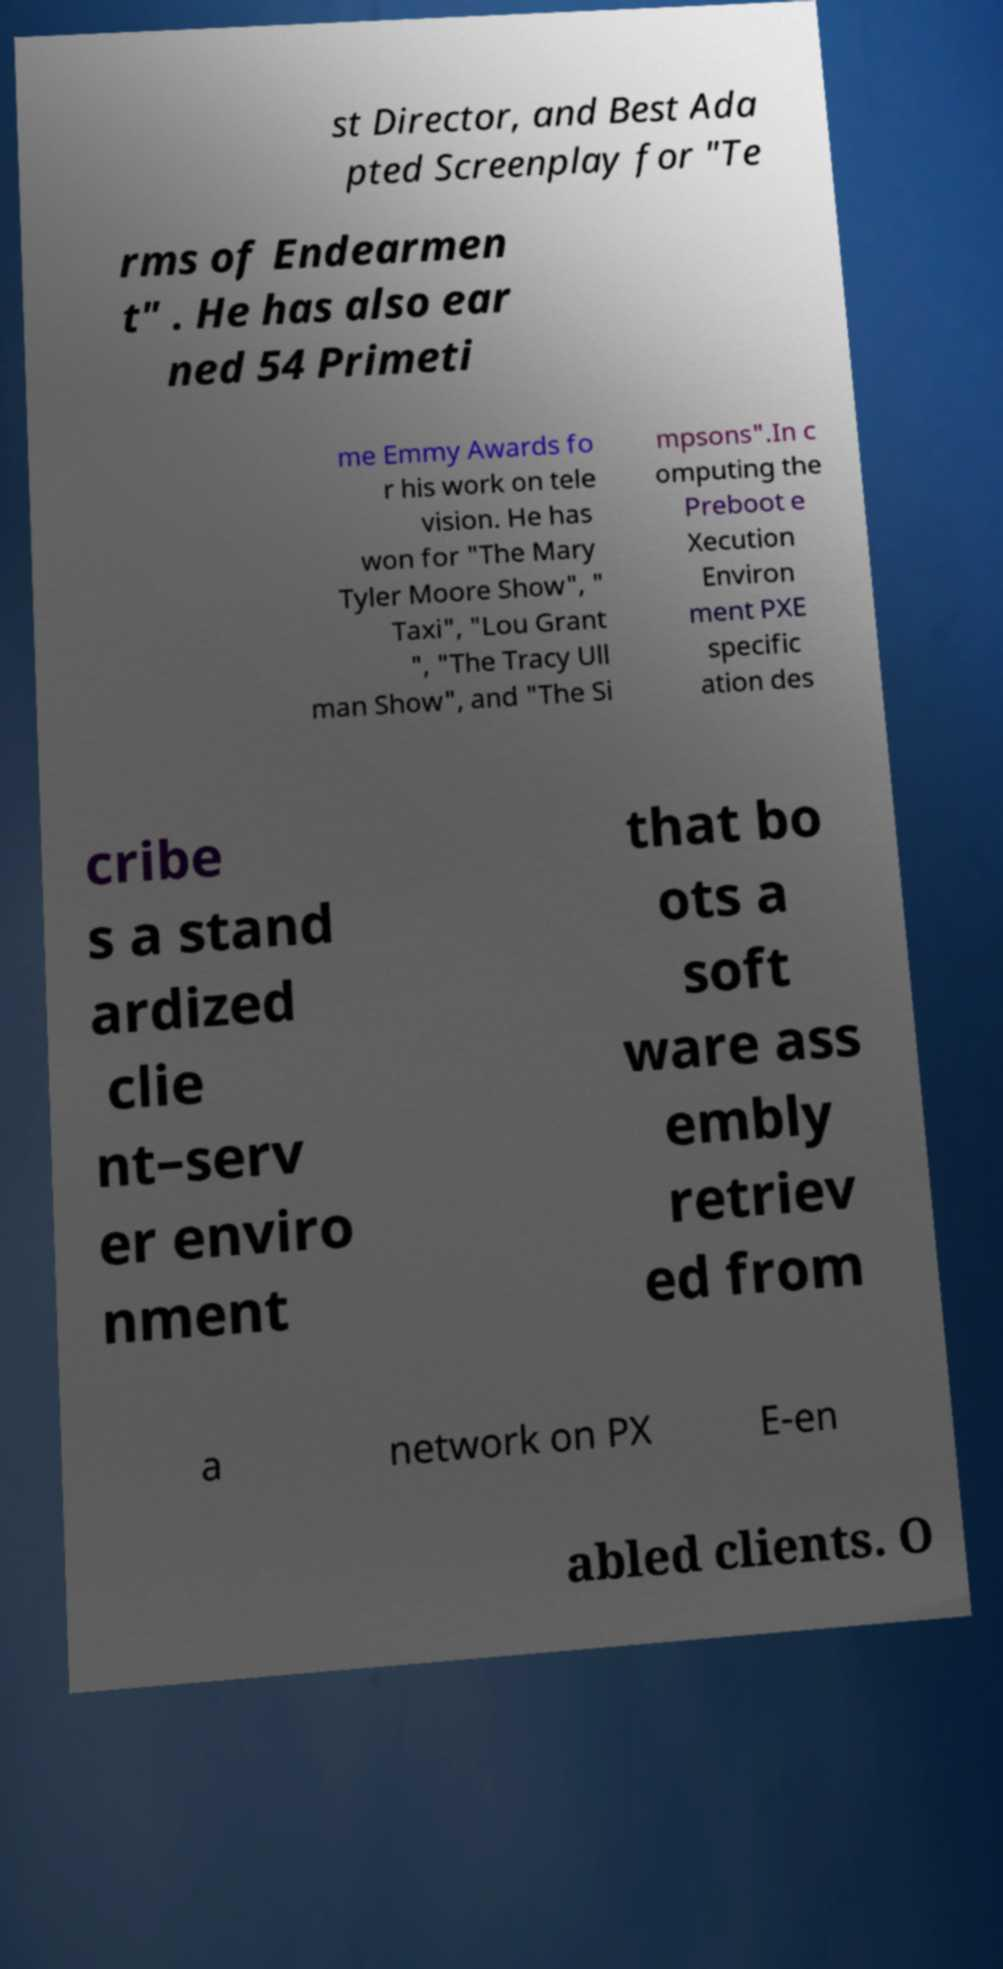I need the written content from this picture converted into text. Can you do that? st Director, and Best Ada pted Screenplay for "Te rms of Endearmen t" . He has also ear ned 54 Primeti me Emmy Awards fo r his work on tele vision. He has won for "The Mary Tyler Moore Show", " Taxi", "Lou Grant ", "The Tracy Ull man Show", and "The Si mpsons".In c omputing the Preboot e Xecution Environ ment PXE specific ation des cribe s a stand ardized clie nt–serv er enviro nment that bo ots a soft ware ass embly retriev ed from a network on PX E-en abled clients. O 